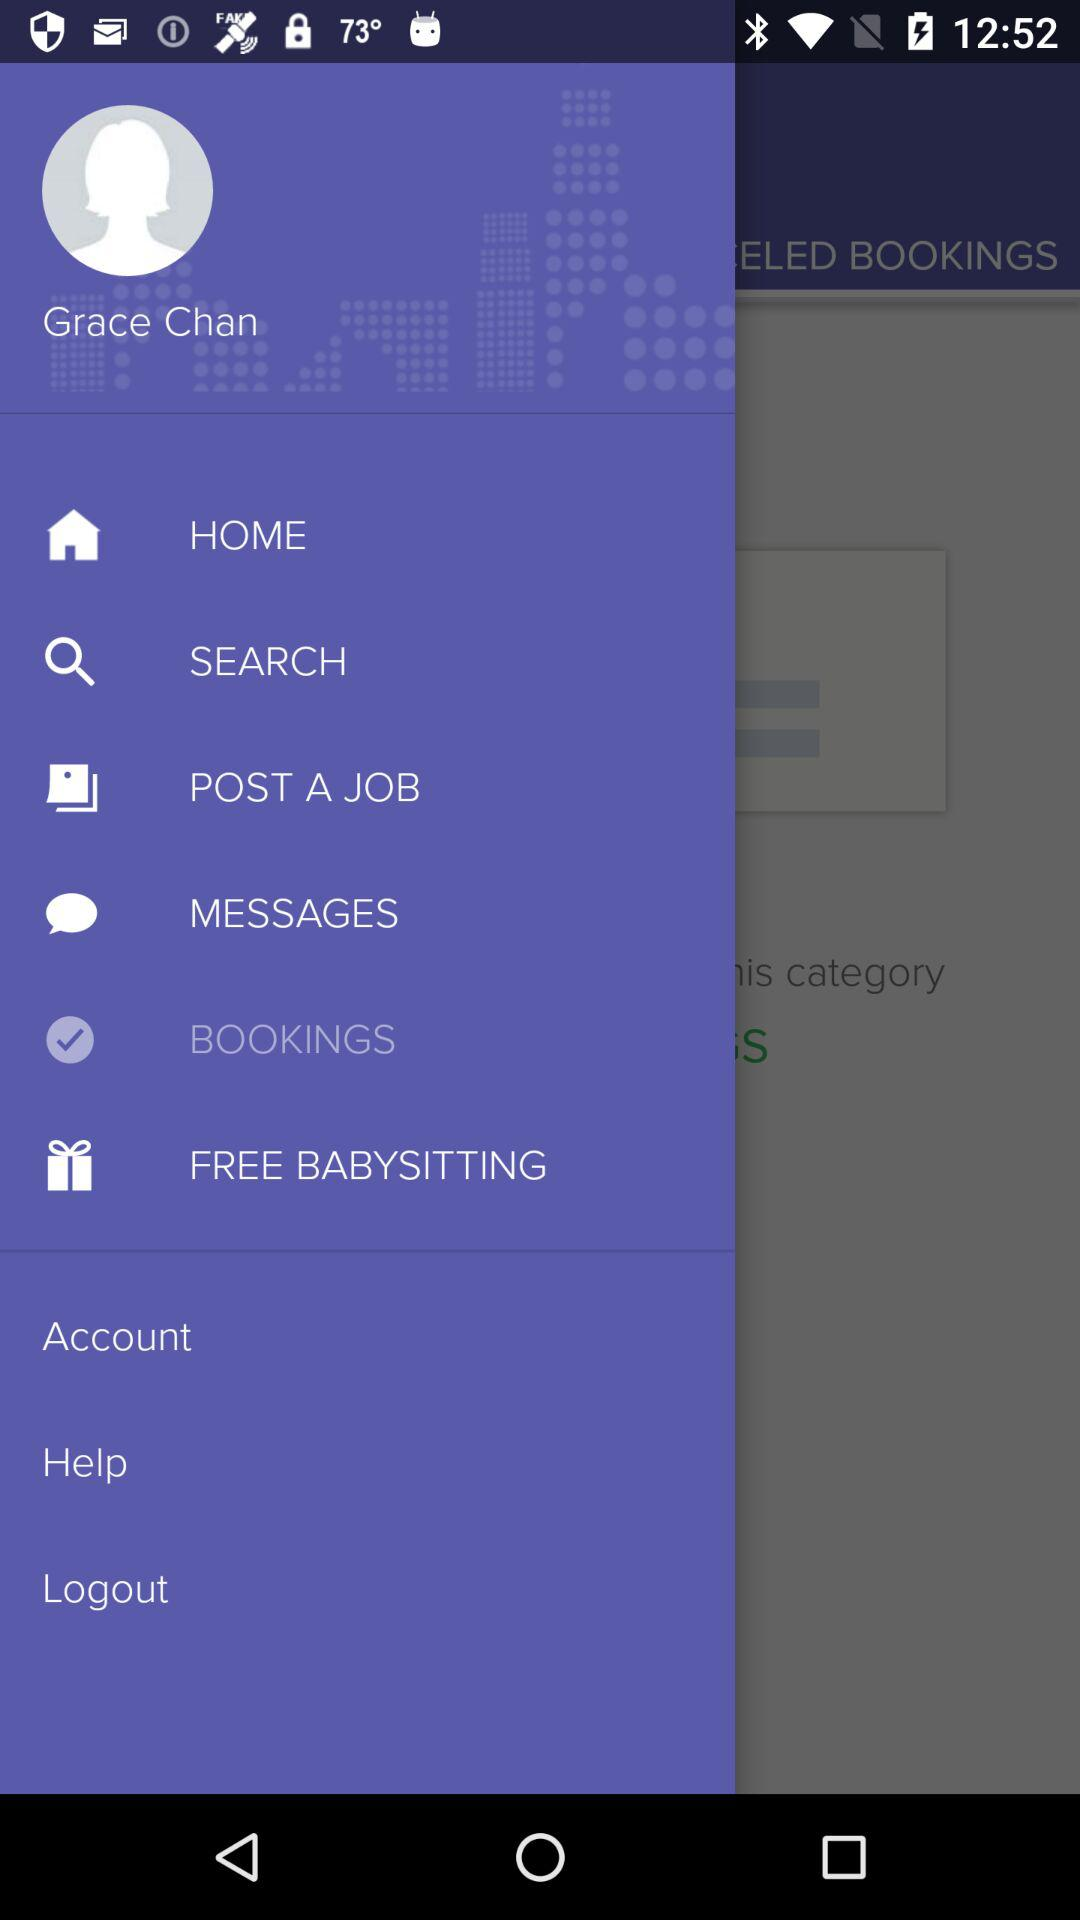What is the name of the user? The name of the user is Grace Chan. 